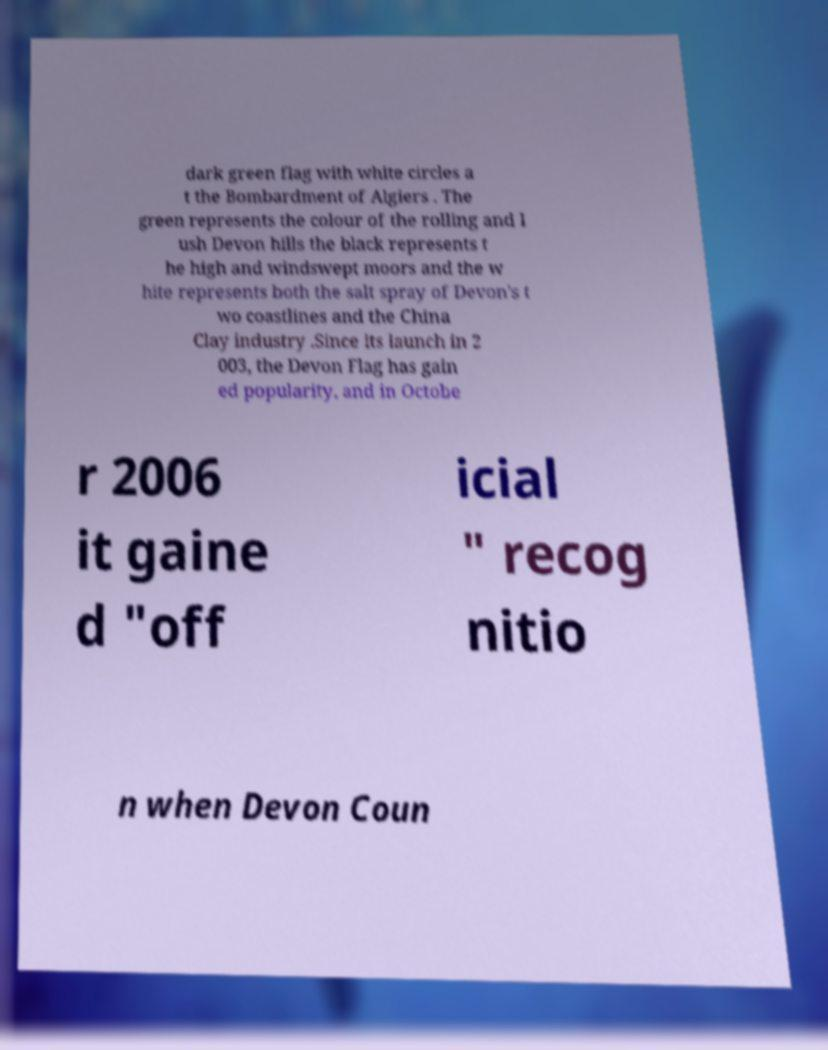Could you extract and type out the text from this image? dark green flag with white circles a t the Bombardment of Algiers . The green represents the colour of the rolling and l ush Devon hills the black represents t he high and windswept moors and the w hite represents both the salt spray of Devon's t wo coastlines and the China Clay industry .Since its launch in 2 003, the Devon Flag has gain ed popularity, and in Octobe r 2006 it gaine d "off icial " recog nitio n when Devon Coun 